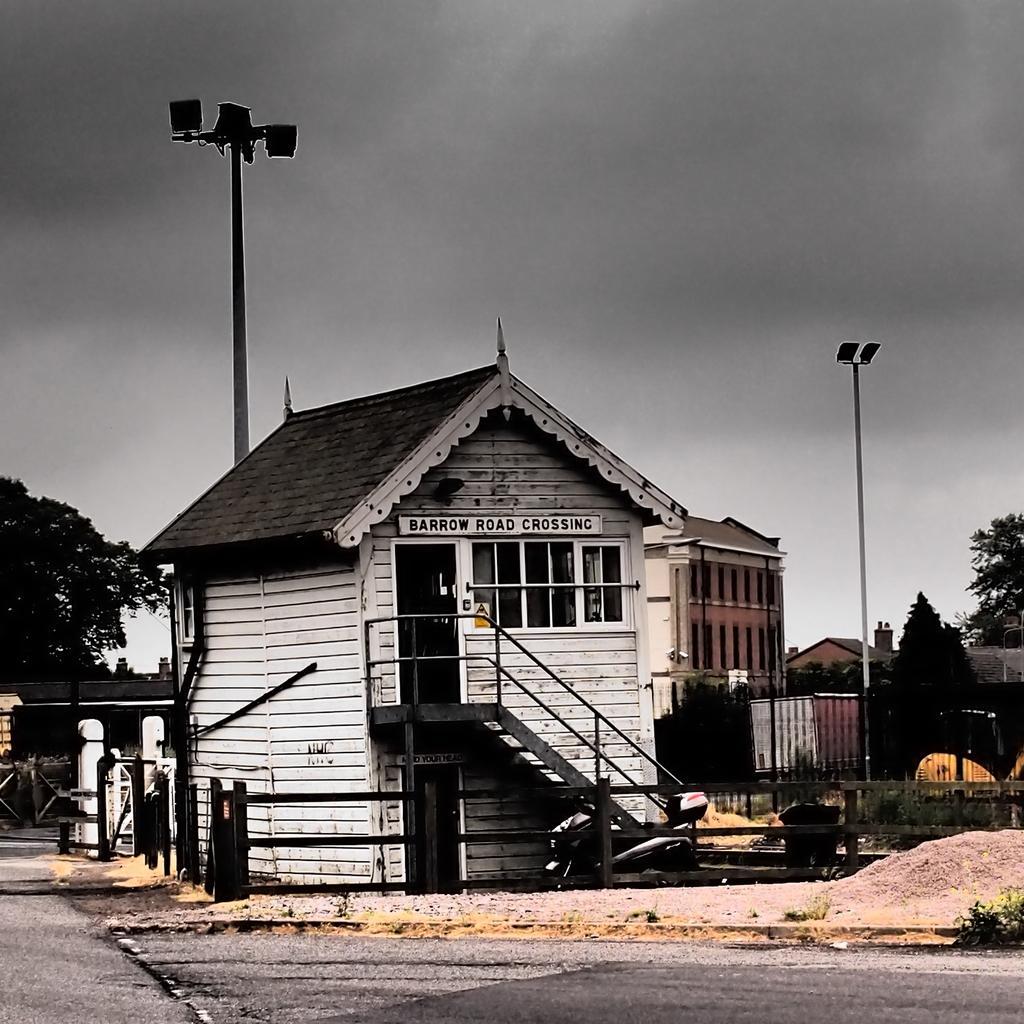Please provide a concise description of this image. There is a wooden house, which is having glass windows near a road. In the background, there are lights attached to poles, buildings, trees and clouds in the sky. 